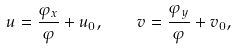<formula> <loc_0><loc_0><loc_500><loc_500>u = \frac { \varphi _ { x } } \varphi + u _ { 0 } , \quad v = \frac { \varphi _ { y } } \varphi + v _ { 0 } ,</formula> 